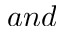<formula> <loc_0><loc_0><loc_500><loc_500>a n d</formula> 